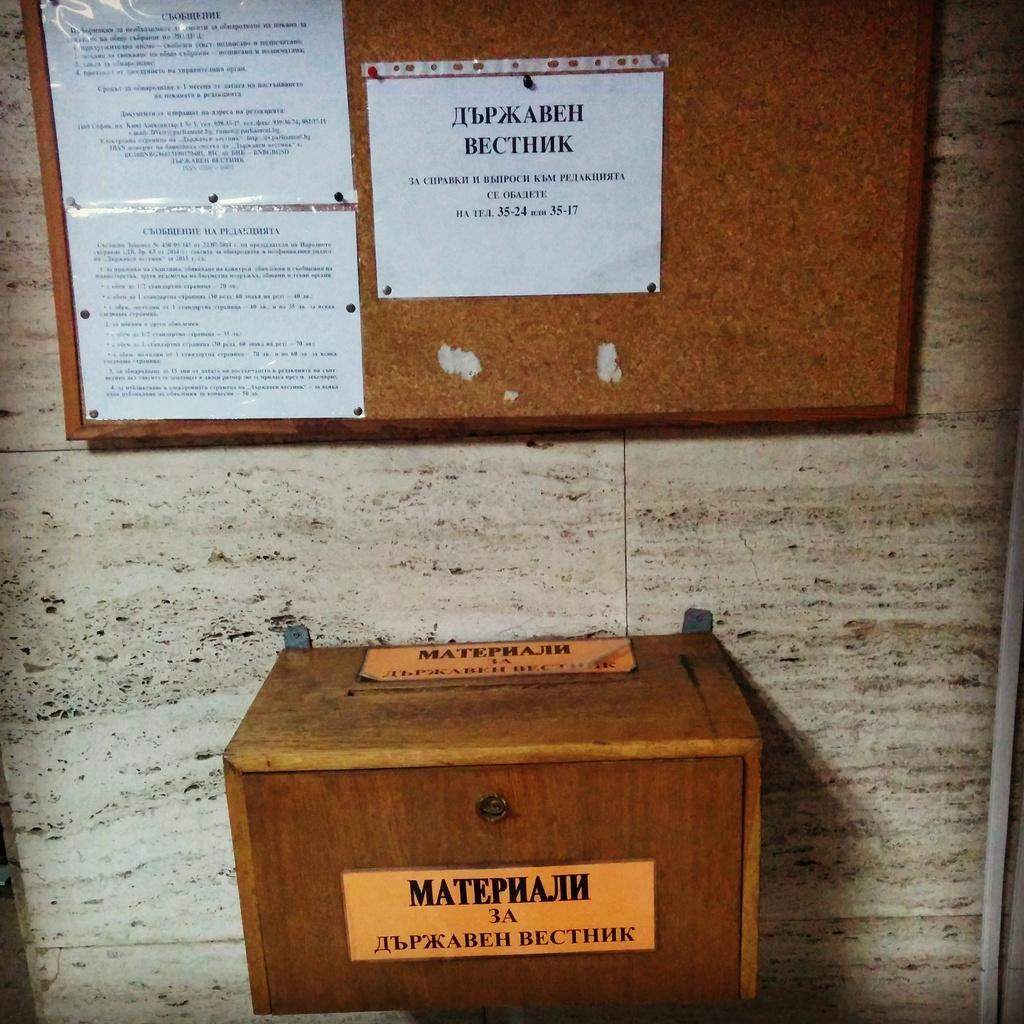<image>
Write a terse but informative summary of the picture. A wooden box with a label on the front of the box saying MatephajIh 3A with a bulletin board behind it. 